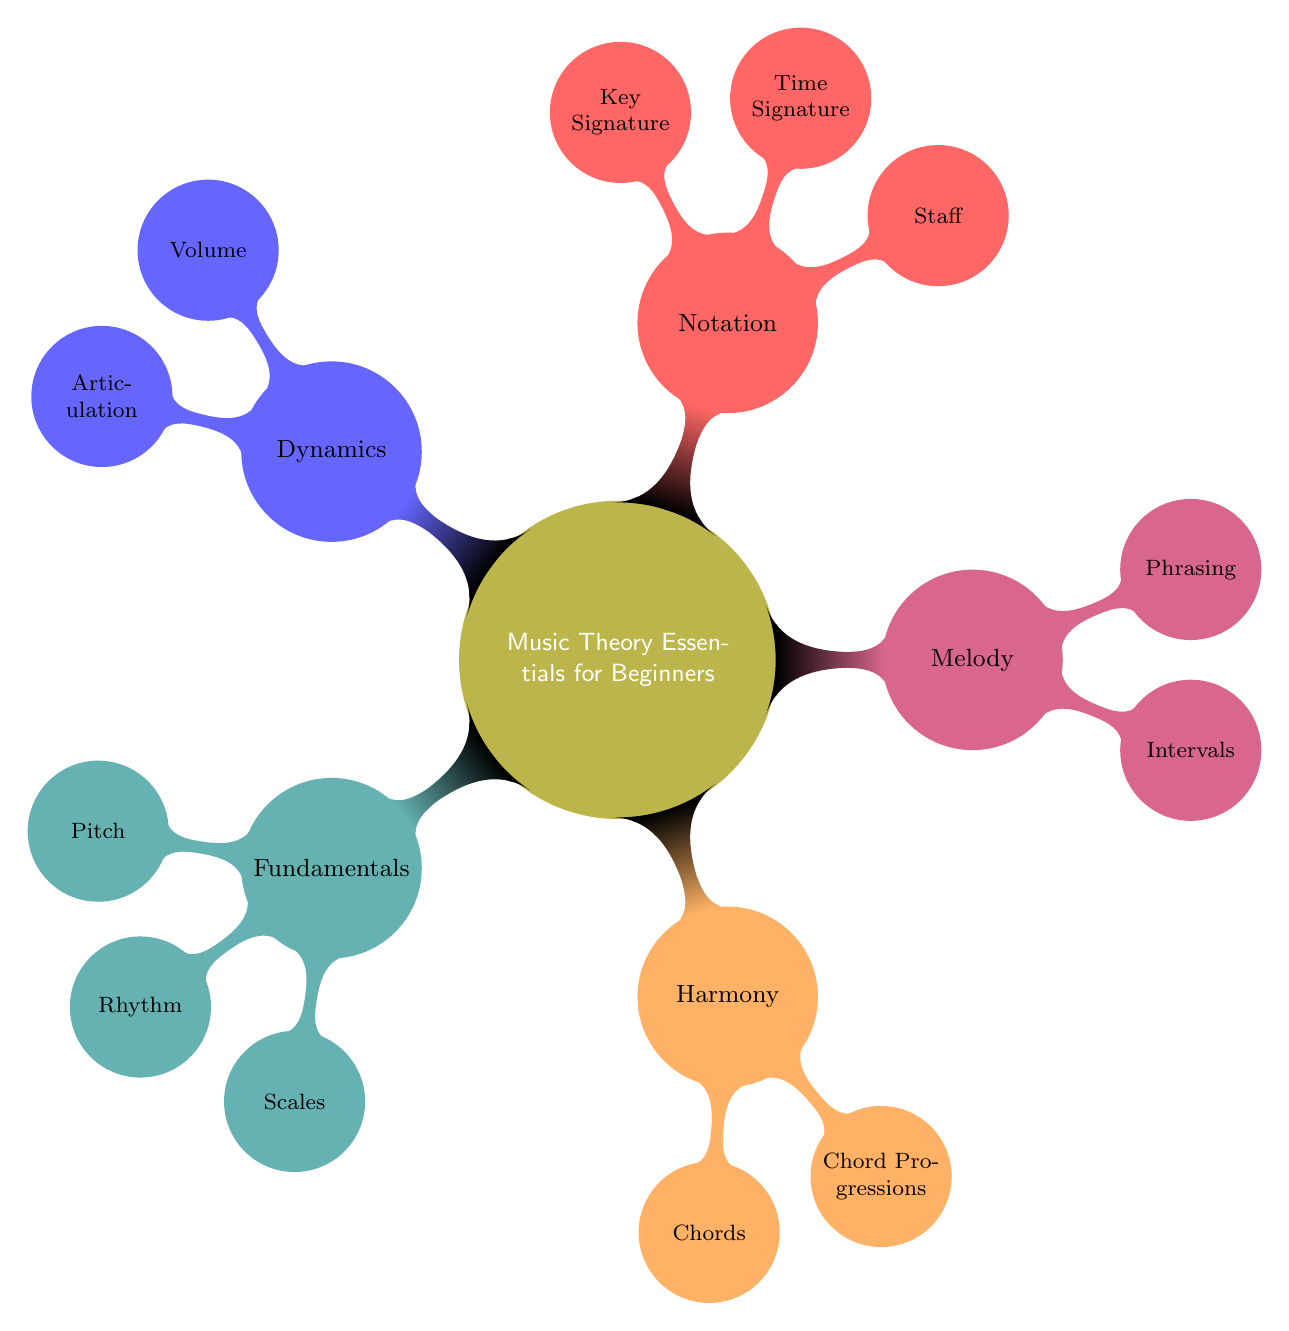What are the three main branches of music theory? The diagram shows five main branches, but focusing on the three major ones, they are Fundamentals, Harmony, and Melody.
Answer: Fundamentals, Harmony, Melody How many types of notes are included in the rhythm section? The rhythm section in the diagram includes five types of notes: Whole Notes, Half Notes, Quarter Notes, Eighth Notes, and Sixteenth Notes. Counting these gives a total of five.
Answer: Five What are the types of chords listed under Harmony? In the Harmony section, there are three types of chords mentioned: Major Chords, Minor Chords, and Sevenths.
Answer: Major Chords, Minor Chords, Sevenths Which node is connected to the Concepts of Dynamics? The Dynamics section connects to two concepts: Volume and Articulation. This shows the focus on sound variations within music dynamics.
Answer: Volume, Articulation What is the key signature notation indicated in the diagram? Under Notation, the Key Signature includes two types: Sharps and Flats. This indicates how these signs represent different pitches in music notation.
Answer: Sharps, Flats How does the Melody branch relate to Phrasing? The Melody branch is made up of two main components: Intervals and Phrasing. This indicates that Phrasing is an integral aspect of constructing melodies.
Answer: Phrasing is part of Melody What is the time signature listed under Notation? The Notation section encompasses three time signatures: 4/4, 3/4, and 2/4. This demonstrates the various rhythmic frameworks in which music is notated.
Answer: 4/4, 3/4, 2/4 How many nodes are there within the Fundamentals branch? The Fundamentals branch comprises three primary nodes: Pitch, Rhythm, and Scales. Therefore, there are three nodes in total within this branch.
Answer: Three 